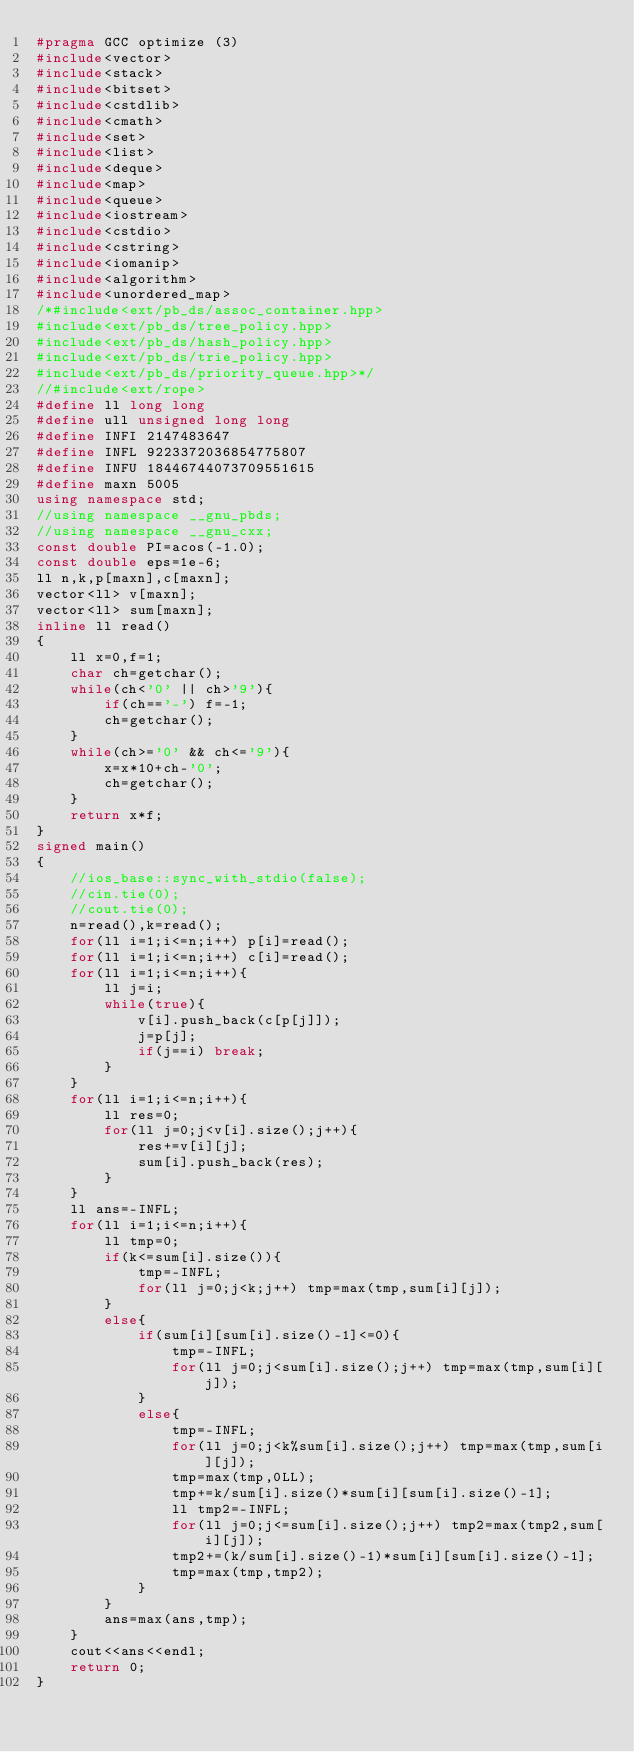Convert code to text. <code><loc_0><loc_0><loc_500><loc_500><_C++_>#pragma GCC optimize (3)
#include<vector>
#include<stack>
#include<bitset>
#include<cstdlib>
#include<cmath>
#include<set>
#include<list>
#include<deque>
#include<map>
#include<queue>
#include<iostream>
#include<cstdio>
#include<cstring>
#include<iomanip>
#include<algorithm>
#include<unordered_map>
/*#include<ext/pb_ds/assoc_container.hpp>
#include<ext/pb_ds/tree_policy.hpp>
#include<ext/pb_ds/hash_policy.hpp>
#include<ext/pb_ds/trie_policy.hpp>
#include<ext/pb_ds/priority_queue.hpp>*/
//#include<ext/rope>
#define ll long long
#define ull unsigned long long
#define INFI 2147483647
#define INFL 9223372036854775807
#define INFU 18446744073709551615
#define maxn 5005
using namespace std;
//using namespace __gnu_pbds;
//using namespace __gnu_cxx;
const double PI=acos(-1.0);
const double eps=1e-6;
ll n,k,p[maxn],c[maxn];
vector<ll> v[maxn];
vector<ll> sum[maxn];
inline ll read()
{
    ll x=0,f=1;
    char ch=getchar();
    while(ch<'0' || ch>'9'){
        if(ch=='-') f=-1;
        ch=getchar();
    }
    while(ch>='0' && ch<='9'){
        x=x*10+ch-'0';
        ch=getchar();
    }
    return x*f;
}
signed main()
{
    //ios_base::sync_with_stdio(false);
    //cin.tie(0);
    //cout.tie(0);
    n=read(),k=read();
    for(ll i=1;i<=n;i++) p[i]=read();
    for(ll i=1;i<=n;i++) c[i]=read();
    for(ll i=1;i<=n;i++){
        ll j=i;
        while(true){
            v[i].push_back(c[p[j]]);
            j=p[j];
            if(j==i) break;
        }
    }
    for(ll i=1;i<=n;i++){
        ll res=0;
        for(ll j=0;j<v[i].size();j++){
            res+=v[i][j];
            sum[i].push_back(res);
        }
    }
    ll ans=-INFL;
    for(ll i=1;i<=n;i++){
        ll tmp=0;
        if(k<=sum[i].size()){
            tmp=-INFL;
            for(ll j=0;j<k;j++) tmp=max(tmp,sum[i][j]);
        }
        else{
            if(sum[i][sum[i].size()-1]<=0){
                tmp=-INFL;
                for(ll j=0;j<sum[i].size();j++) tmp=max(tmp,sum[i][j]);
            }
            else{
                tmp=-INFL;
                for(ll j=0;j<k%sum[i].size();j++) tmp=max(tmp,sum[i][j]);
                tmp=max(tmp,0LL);
                tmp+=k/sum[i].size()*sum[i][sum[i].size()-1];
                ll tmp2=-INFL;
                for(ll j=0;j<=sum[i].size();j++) tmp2=max(tmp2,sum[i][j]);
                tmp2+=(k/sum[i].size()-1)*sum[i][sum[i].size()-1];
                tmp=max(tmp,tmp2);
            }
        }
        ans=max(ans,tmp);
    }
    cout<<ans<<endl;
    return 0;
}
</code> 